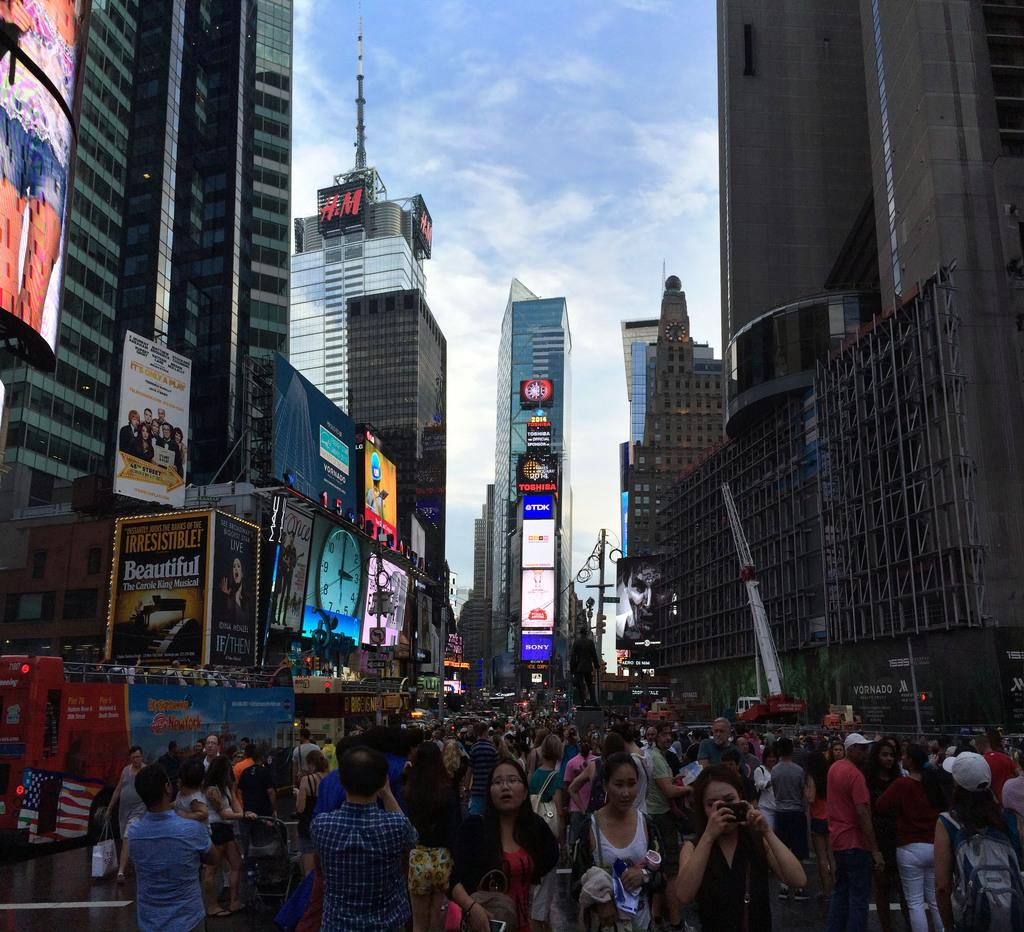<image>
Render a clear and concise summary of the photo. The city of New York crowded with tourists with many ads on the buildings like H and M and Beautiful movie. 